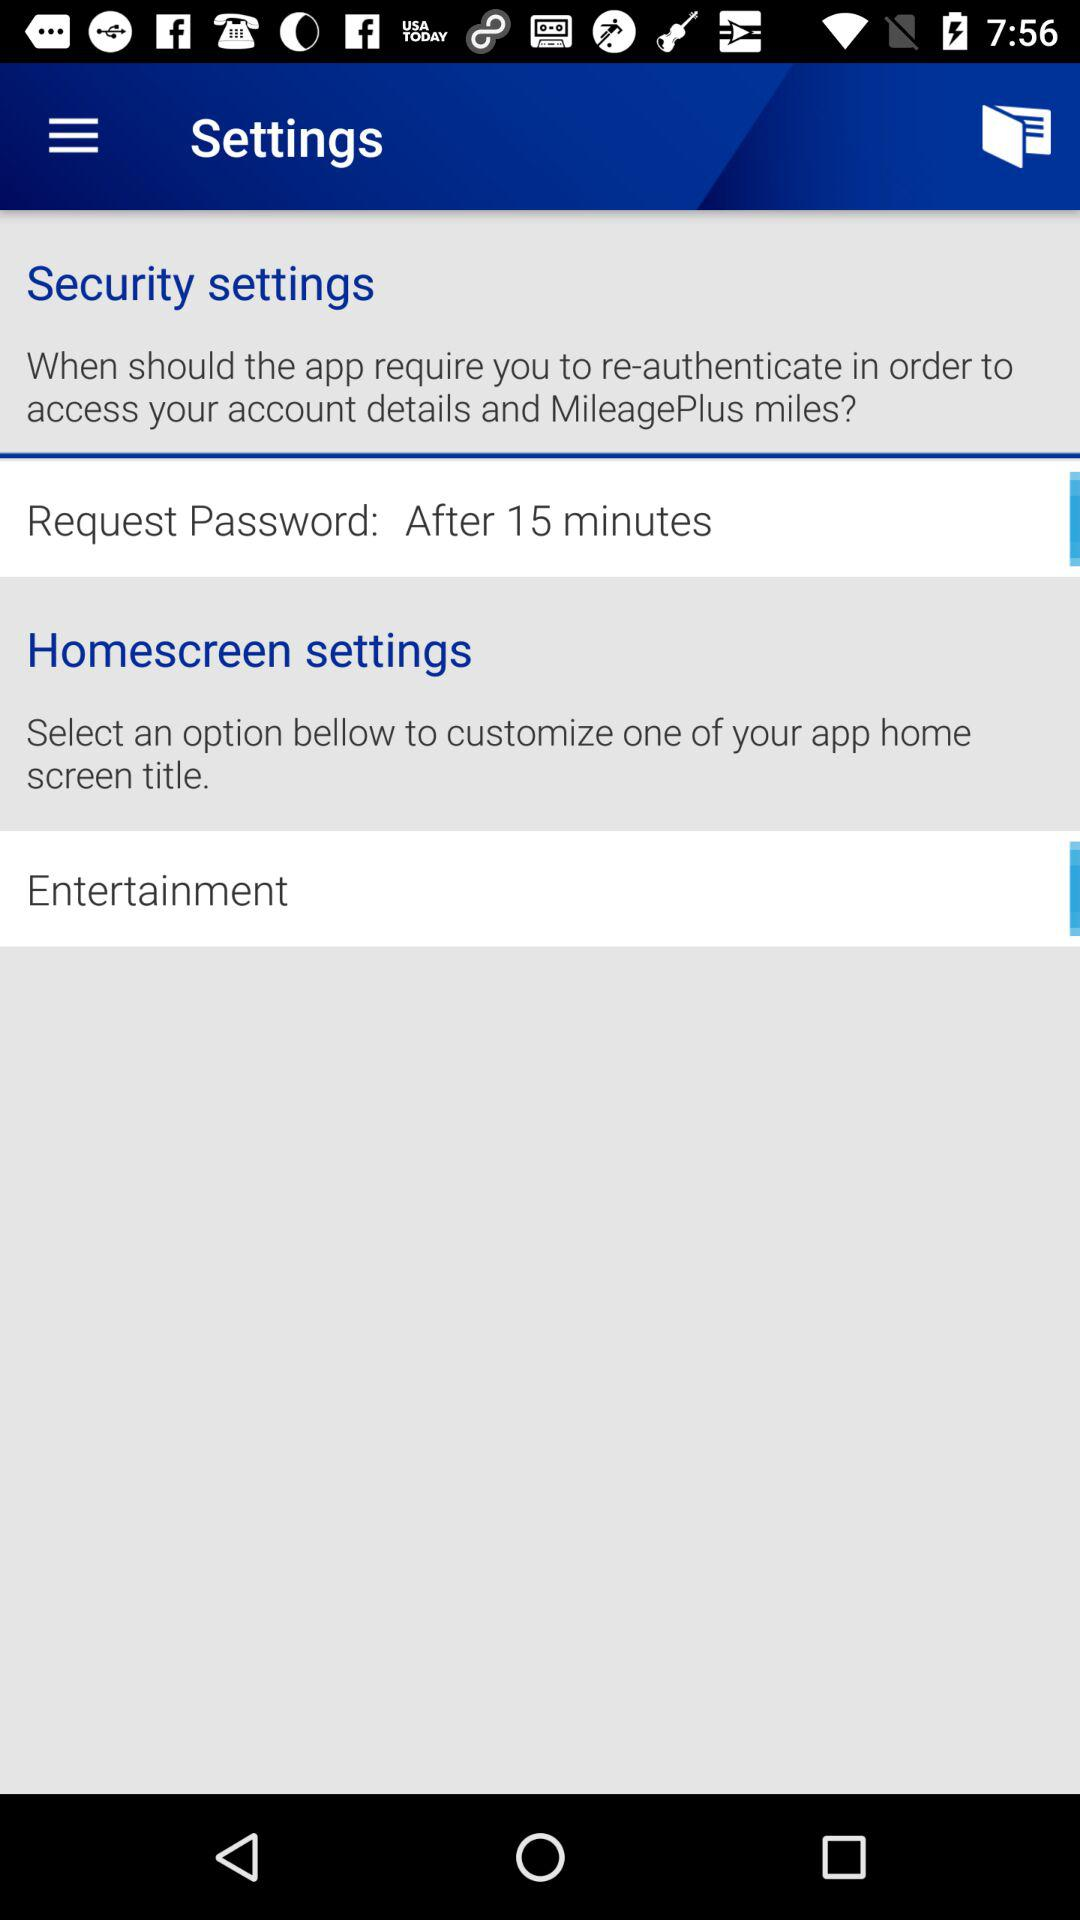How long will a person have to wait for a password request? A person can request a password after 15 minutes. 